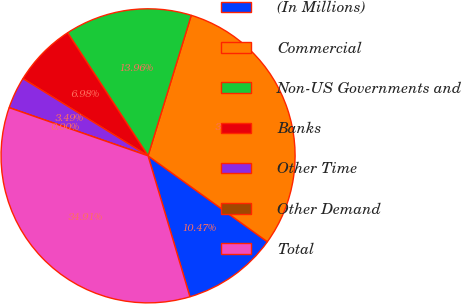<chart> <loc_0><loc_0><loc_500><loc_500><pie_chart><fcel>(In Millions)<fcel>Commercial<fcel>Non-US Governments and<fcel>Banks<fcel>Other Time<fcel>Other Demand<fcel>Total<nl><fcel>10.47%<fcel>30.18%<fcel>13.96%<fcel>6.98%<fcel>3.49%<fcel>0.0%<fcel>34.9%<nl></chart> 